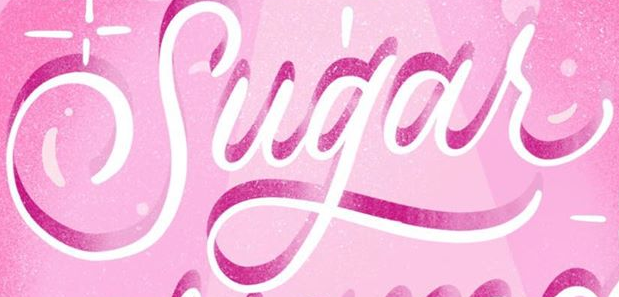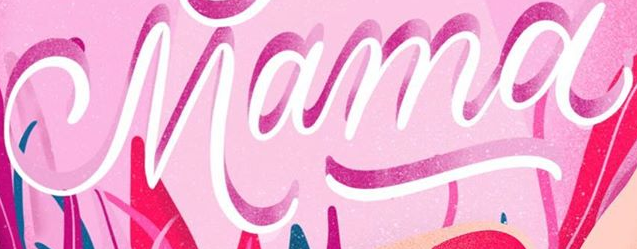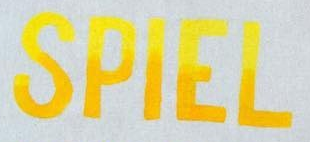What text appears in these images from left to right, separated by a semicolon? Sugar; Mama; SPIEL 